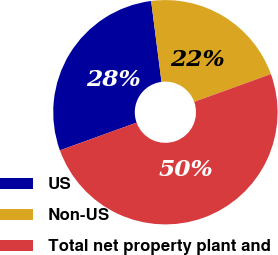Convert chart to OTSL. <chart><loc_0><loc_0><loc_500><loc_500><pie_chart><fcel>US<fcel>Non-US<fcel>Total net property plant and<nl><fcel>28.49%<fcel>21.51%<fcel>50.0%<nl></chart> 